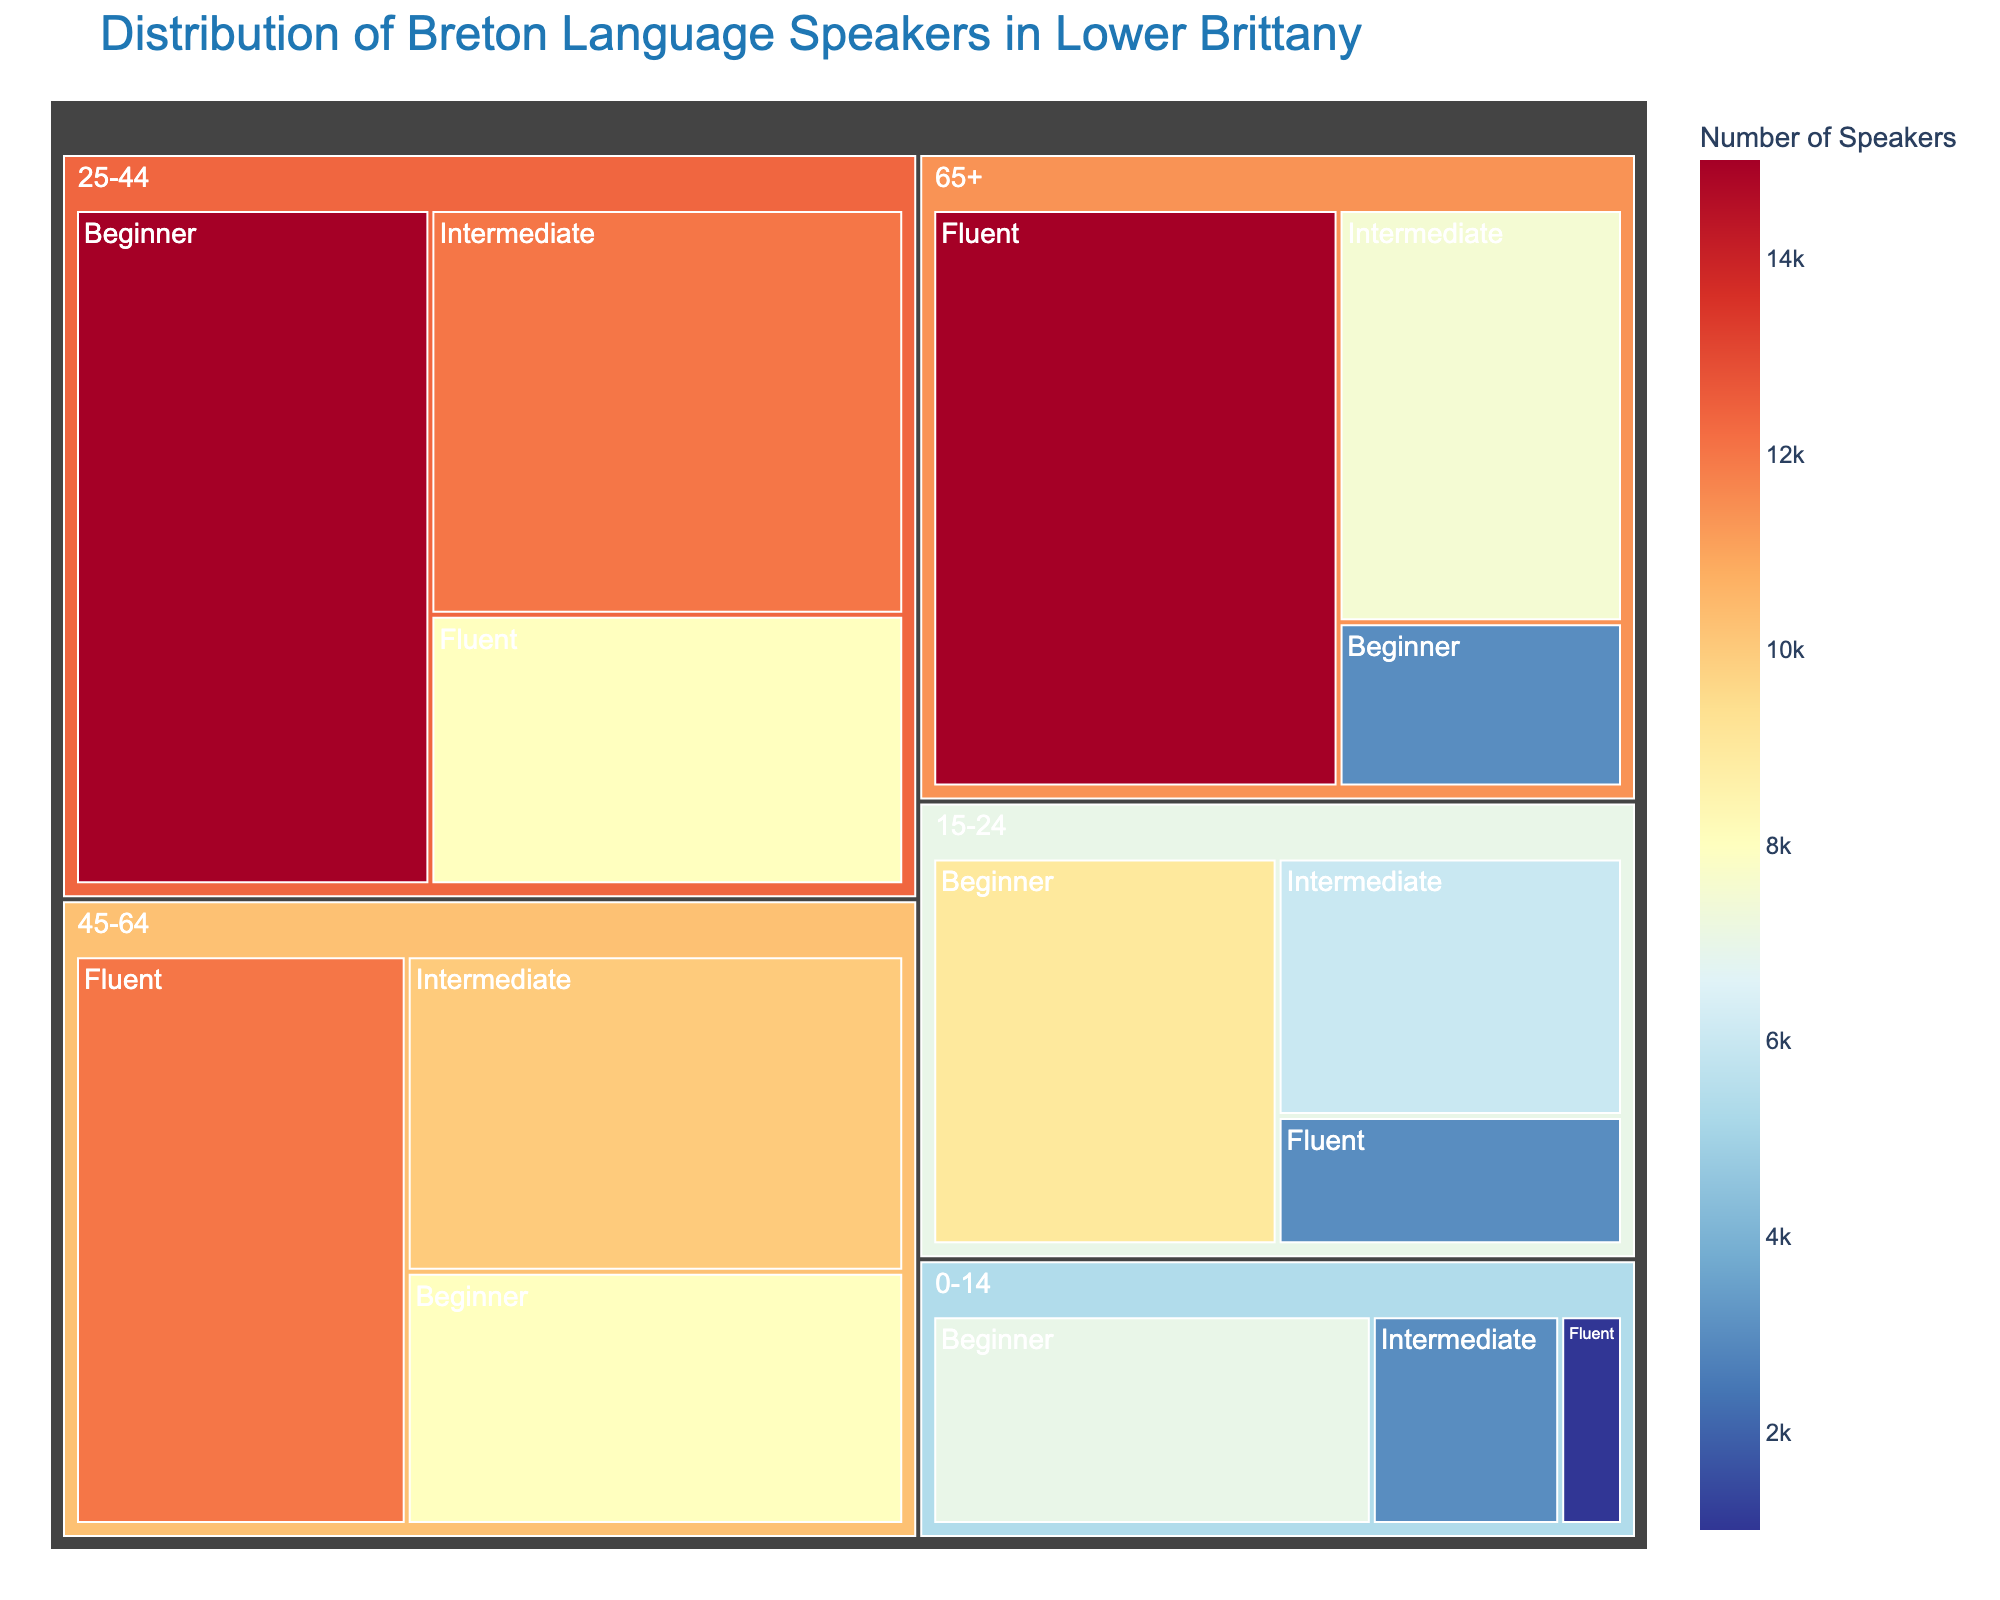What is the title of the treemap? The title of the treemap is located at the top of the figure and typically provides a concise summary of the data being visualized.
Answer: Distribution of Breton Language Speakers in Lower Brittany Which age group has the highest number of fluent speakers? To find the age group with the highest number of fluent speakers, look at the section labeled "Fluent" under different age groups and compare their sizes or the number of speakers. The largest or tallest section will correspond to the age group with the highest number of fluent speakers.
Answer: 65+ How many fluent speakers are there in the 15-24 age group? Look under the "15-24" age group and find the section labeled "Fluent" to identify the number of speakers.
Answer: 3,000 What is the total number of speakers (all proficiency levels) in the 25-44 age group? Add the numbers of speakers in the "Fluent," "Intermediate," and "Beginner" sections under the "25-44" age group. The summation is 8000 + 12000 + 15000.
Answer: 35,000 Is the number of intermediate speakers greater than beginner speakers in the 45-64 age group? Compare the sizes or the numbers in the "Intermediate" and "Beginner" sections under the "45-64" age group.
Answer: No What is the proportion of beginner speakers among the total speakers in the 0-14 age group? First, find the total number of speakers in the 0-14 age group by summing the "Fluent," "Intermediate," and "Beginner" speakers. Then, divide the number of "Beginner" speakers by this sum and multiply by 100 to get the percentage. (1000 + 3000 + 7000) = 11000, and 7000/11000 ≈ 63.6%.
Answer: 63.6% Which proficiency level has the most speakers overall? Sum the number of speakers at each proficiency level (Fluent, Intermediate, Beginner) across all age groups. The level with the highest total is the one with the most speakers. Summing gives: Fluent = 39,000, Intermediate = 38,500, Beginner = 42,000.
Answer: Beginner How does the number of fluent speakers in the 0-14 age group compare to the number in the 65+ age group? Compare the numbers in the "Fluent" sections of the "0-14" age group and the "65+" age group. The number in "0-14" is 1,000 and in "65+" is 15,000.
Answer: Significantly lower 